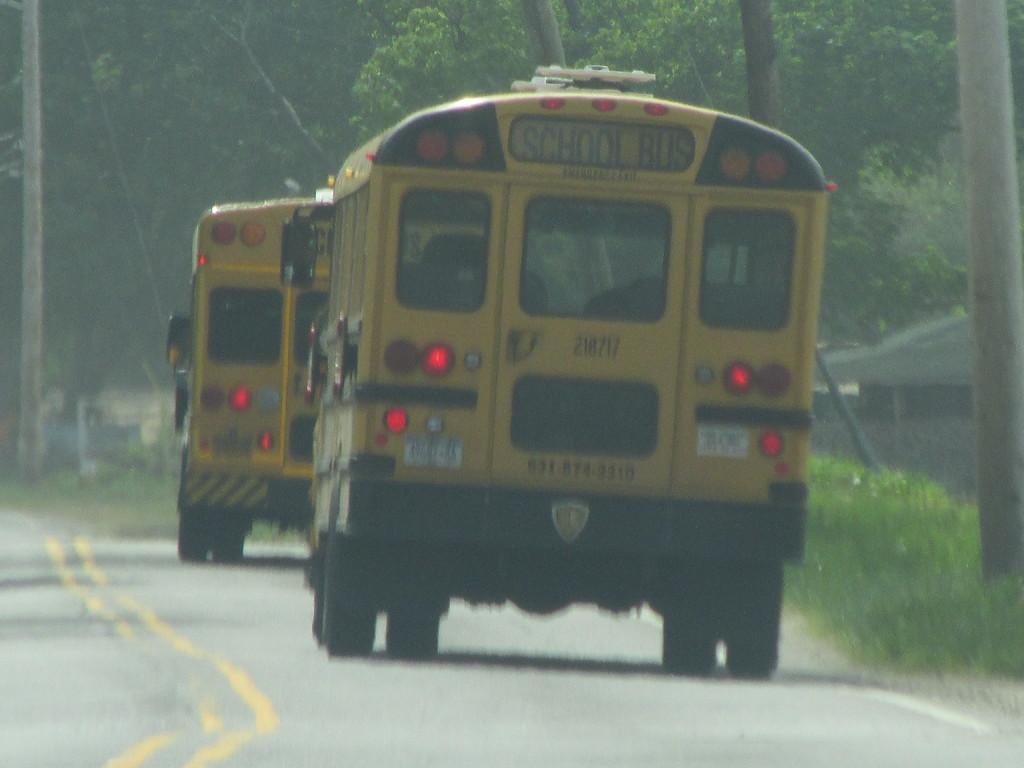Could you give a brief overview of what you see in this image? In this image, we can see buses on the road and in the background, there are trees and we can see sheds. 